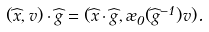<formula> <loc_0><loc_0><loc_500><loc_500>( \widehat { x } , v ) \cdot \widehat { g } = ( \widehat { x } \cdot \widehat { g } , \rho _ { 0 } ( \widehat { g } ^ { - 1 } ) v ) .</formula> 